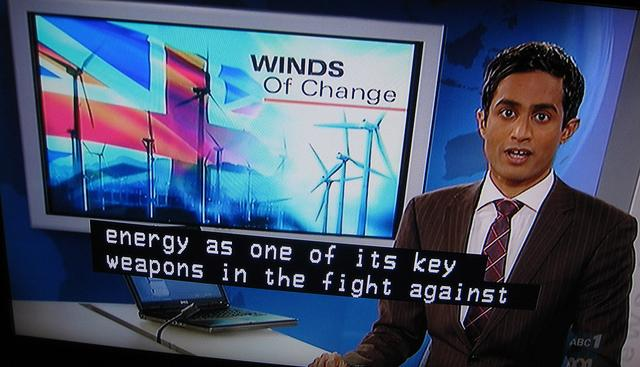Which national flag is in the segment screen of this broadcast?

Choices:
A) france
B) uk
C) netherlands
D) german uk 